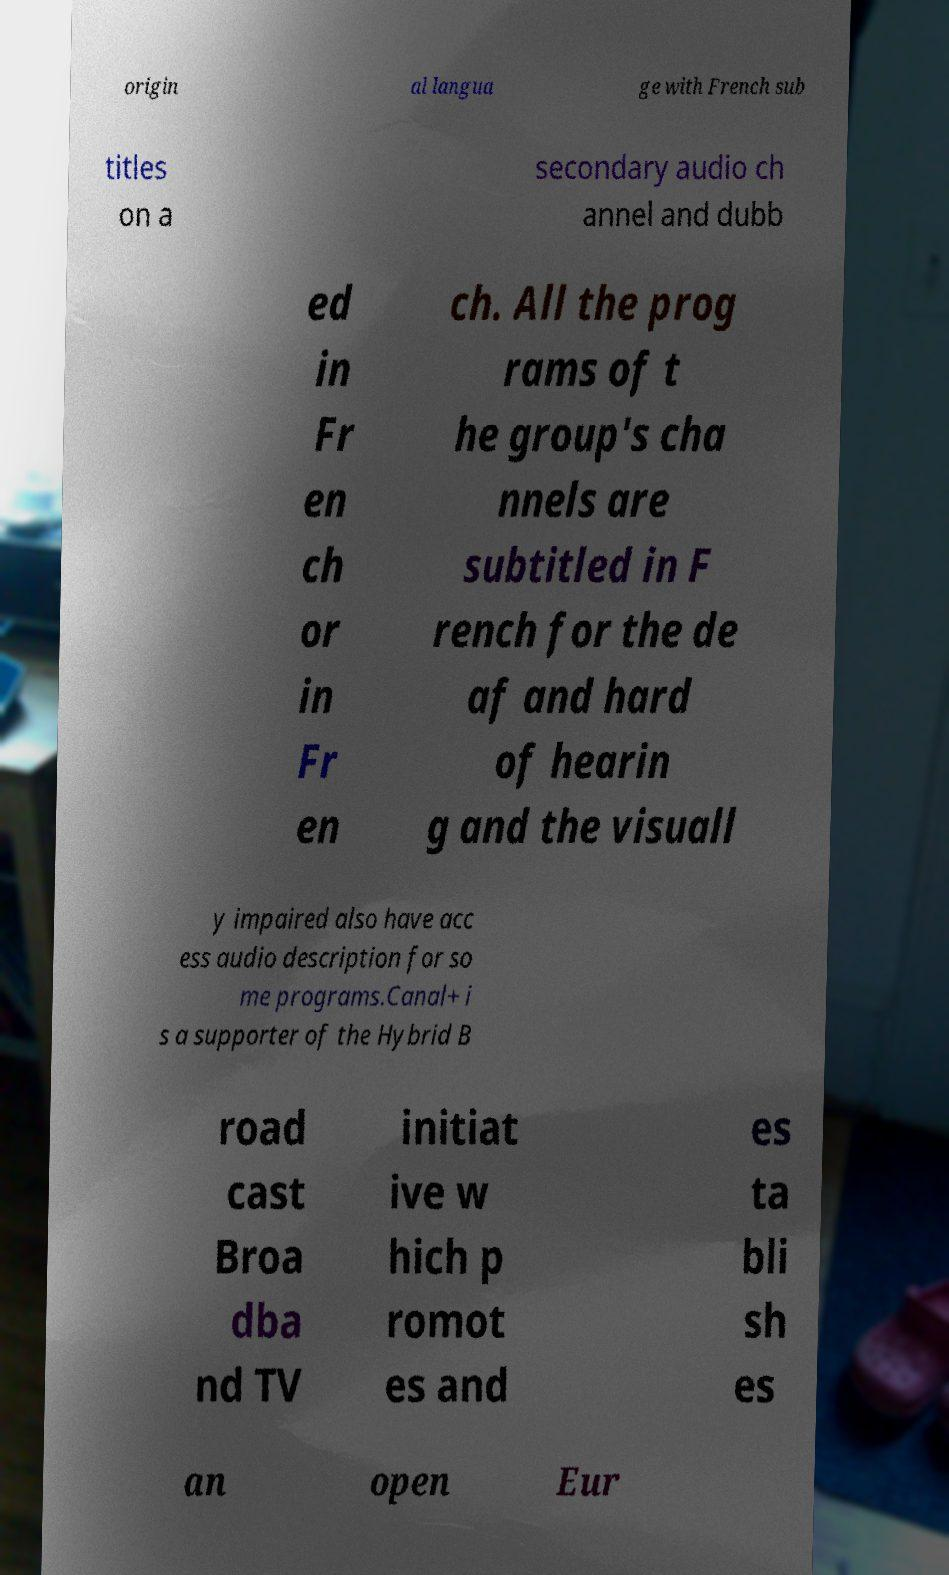Could you extract and type out the text from this image? origin al langua ge with French sub titles on a secondary audio ch annel and dubb ed in Fr en ch or in Fr en ch. All the prog rams of t he group's cha nnels are subtitled in F rench for the de af and hard of hearin g and the visuall y impaired also have acc ess audio description for so me programs.Canal+ i s a supporter of the Hybrid B road cast Broa dba nd TV initiat ive w hich p romot es and es ta bli sh es an open Eur 